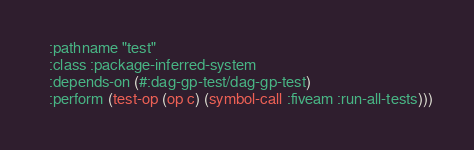<code> <loc_0><loc_0><loc_500><loc_500><_Lisp_>  :pathname "test"
  :class :package-inferred-system
  :depends-on (#:dag-gp-test/dag-gp-test)
  :perform (test-op (op c) (symbol-call :fiveam :run-all-tests)))
</code> 